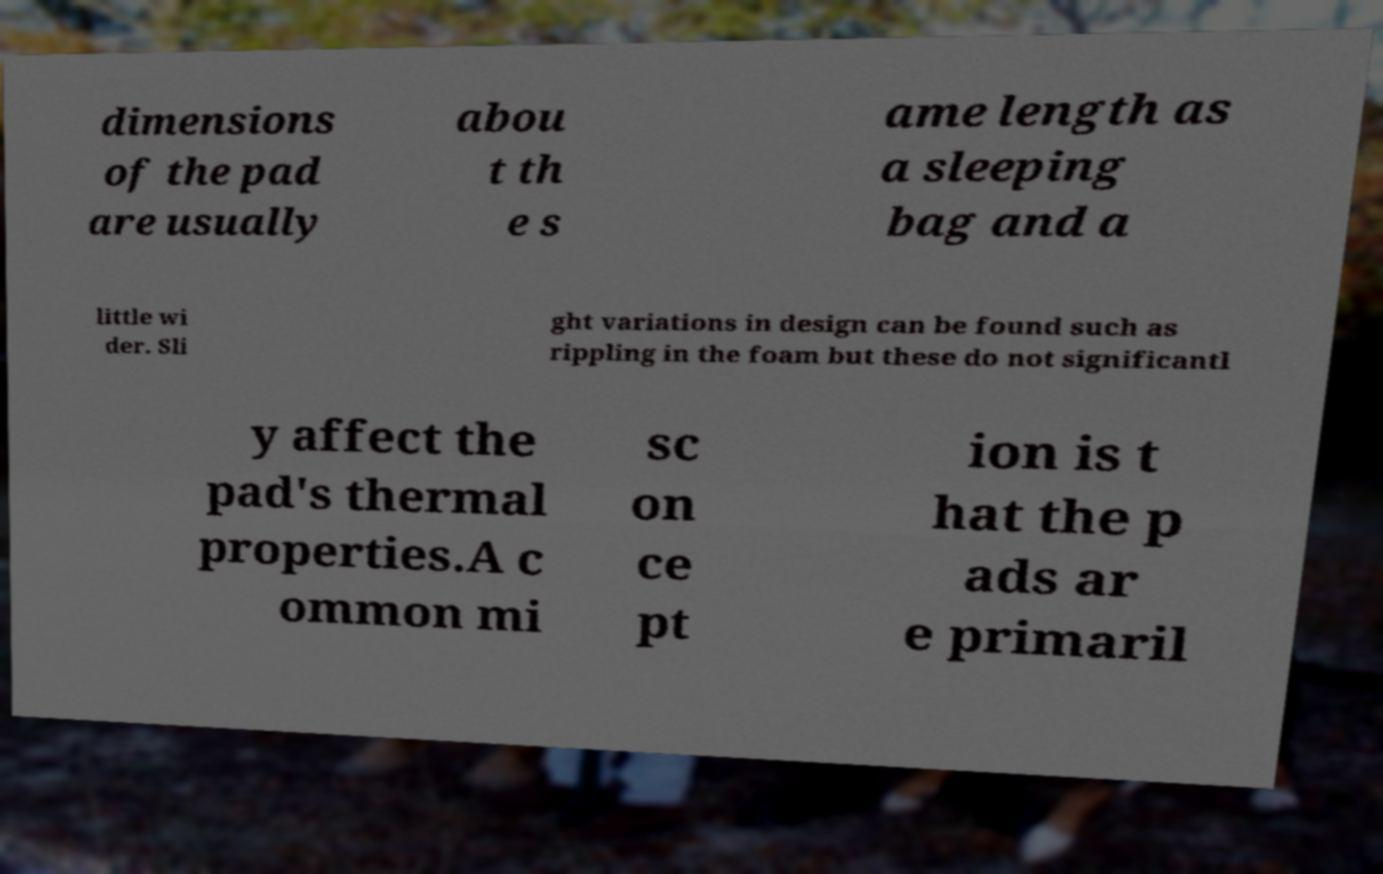Can you accurately transcribe the text from the provided image for me? dimensions of the pad are usually abou t th e s ame length as a sleeping bag and a little wi der. Sli ght variations in design can be found such as rippling in the foam but these do not significantl y affect the pad's thermal properties.A c ommon mi sc on ce pt ion is t hat the p ads ar e primaril 